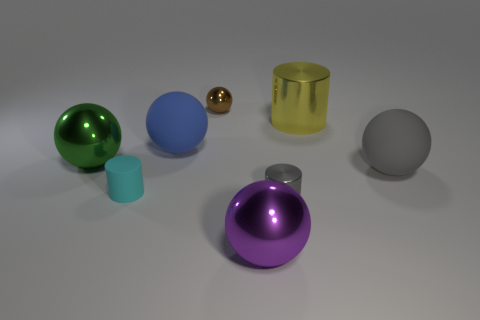What shape is the large thing that is the same color as the tiny shiny cylinder?
Provide a succinct answer. Sphere. The rubber object on the right side of the small gray shiny object that is in front of the big cylinder behind the tiny cyan matte cylinder is what shape?
Make the answer very short. Sphere. There is a sphere that is both right of the blue ball and behind the green thing; what is it made of?
Give a very brief answer. Metal. There is a large blue rubber thing behind the matte object that is to the right of the tiny metal cylinder; what shape is it?
Keep it short and to the point. Sphere. Is there anything else that is the same color as the rubber cylinder?
Give a very brief answer. No. There is a blue ball; is it the same size as the brown object left of the big gray matte thing?
Offer a very short reply. No. What number of large objects are gray rubber cylinders or purple balls?
Give a very brief answer. 1. Are there more gray balls than small cyan metal cylinders?
Give a very brief answer. Yes. There is a shiny cylinder that is behind the rubber ball that is on the right side of the big purple metallic thing; how many large shiny objects are on the right side of it?
Your answer should be compact. 0. What is the shape of the tiny brown metal object?
Offer a very short reply. Sphere. 